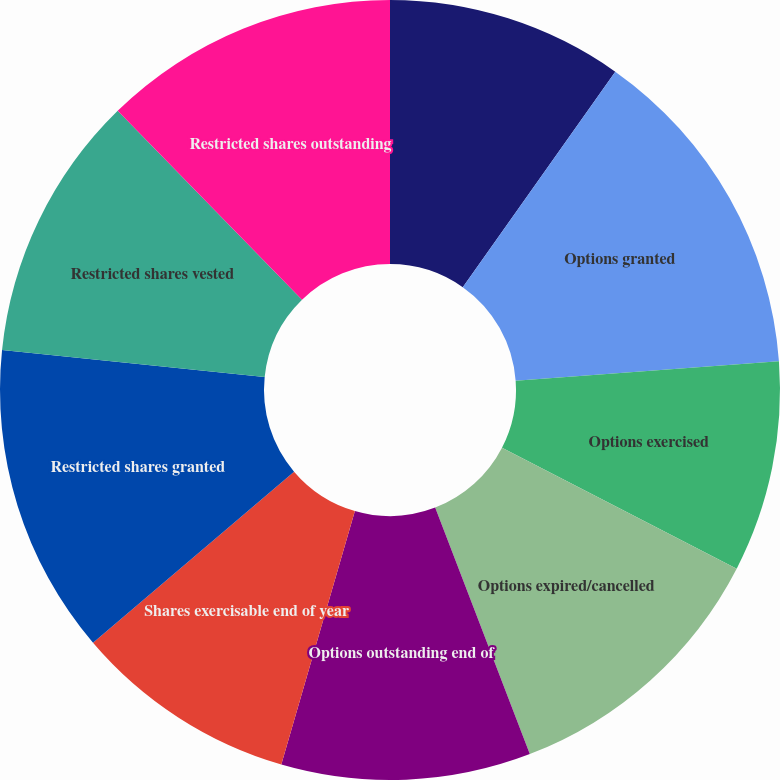Convert chart. <chart><loc_0><loc_0><loc_500><loc_500><pie_chart><fcel>Options outstanding beginning<fcel>Options granted<fcel>Options exercised<fcel>Options expired/cancelled<fcel>Options outstanding end of<fcel>Shares exercisable end of year<fcel>Restricted shares granted<fcel>Restricted shares vested<fcel>Restricted shares outstanding<nl><fcel>9.8%<fcel>14.02%<fcel>8.75%<fcel>11.59%<fcel>10.33%<fcel>9.28%<fcel>12.86%<fcel>11.06%<fcel>12.3%<nl></chart> 